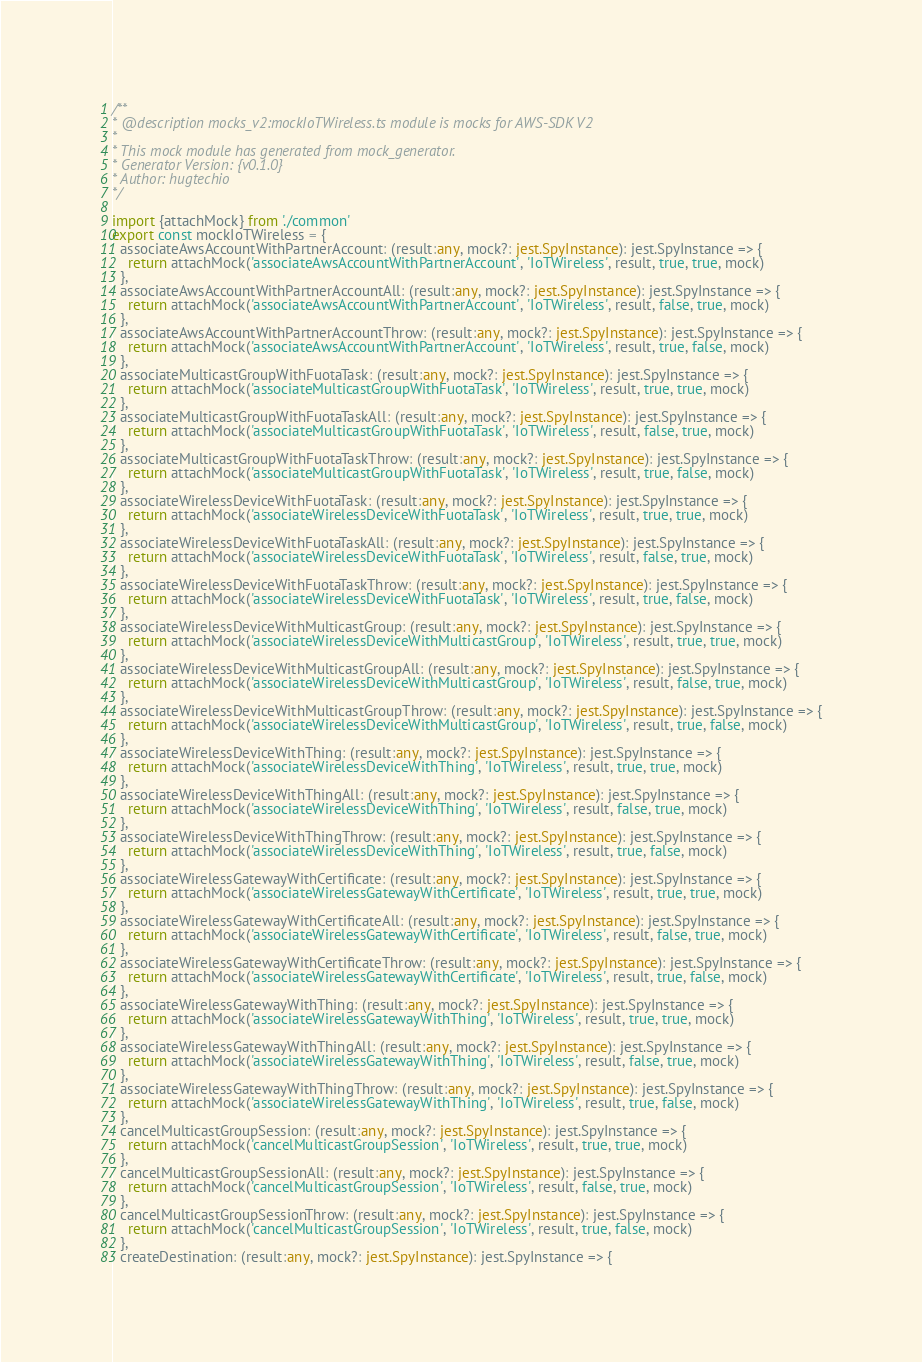<code> <loc_0><loc_0><loc_500><loc_500><_TypeScript_>
/**
* @description mocks_v2:mockIoTWireless.ts module is mocks for AWS-SDK V2
* 
* This mock module has generated from mock_generator.
* Generator Version: {v0.1.0}
* Author: hugtechio
*/

import {attachMock} from './common'
export const mockIoTWireless = {
  associateAwsAccountWithPartnerAccount: (result:any, mock?: jest.SpyInstance): jest.SpyInstance => {
    return attachMock('associateAwsAccountWithPartnerAccount', 'IoTWireless', result, true, true, mock)
  },
  associateAwsAccountWithPartnerAccountAll: (result:any, mock?: jest.SpyInstance): jest.SpyInstance => {
    return attachMock('associateAwsAccountWithPartnerAccount', 'IoTWireless', result, false, true, mock)
  },
  associateAwsAccountWithPartnerAccountThrow: (result:any, mock?: jest.SpyInstance): jest.SpyInstance => {
    return attachMock('associateAwsAccountWithPartnerAccount', 'IoTWireless', result, true, false, mock)
  },
  associateMulticastGroupWithFuotaTask: (result:any, mock?: jest.SpyInstance): jest.SpyInstance => {
    return attachMock('associateMulticastGroupWithFuotaTask', 'IoTWireless', result, true, true, mock)
  },
  associateMulticastGroupWithFuotaTaskAll: (result:any, mock?: jest.SpyInstance): jest.SpyInstance => {
    return attachMock('associateMulticastGroupWithFuotaTask', 'IoTWireless', result, false, true, mock)
  },
  associateMulticastGroupWithFuotaTaskThrow: (result:any, mock?: jest.SpyInstance): jest.SpyInstance => {
    return attachMock('associateMulticastGroupWithFuotaTask', 'IoTWireless', result, true, false, mock)
  },
  associateWirelessDeviceWithFuotaTask: (result:any, mock?: jest.SpyInstance): jest.SpyInstance => {
    return attachMock('associateWirelessDeviceWithFuotaTask', 'IoTWireless', result, true, true, mock)
  },
  associateWirelessDeviceWithFuotaTaskAll: (result:any, mock?: jest.SpyInstance): jest.SpyInstance => {
    return attachMock('associateWirelessDeviceWithFuotaTask', 'IoTWireless', result, false, true, mock)
  },
  associateWirelessDeviceWithFuotaTaskThrow: (result:any, mock?: jest.SpyInstance): jest.SpyInstance => {
    return attachMock('associateWirelessDeviceWithFuotaTask', 'IoTWireless', result, true, false, mock)
  },
  associateWirelessDeviceWithMulticastGroup: (result:any, mock?: jest.SpyInstance): jest.SpyInstance => {
    return attachMock('associateWirelessDeviceWithMulticastGroup', 'IoTWireless', result, true, true, mock)
  },
  associateWirelessDeviceWithMulticastGroupAll: (result:any, mock?: jest.SpyInstance): jest.SpyInstance => {
    return attachMock('associateWirelessDeviceWithMulticastGroup', 'IoTWireless', result, false, true, mock)
  },
  associateWirelessDeviceWithMulticastGroupThrow: (result:any, mock?: jest.SpyInstance): jest.SpyInstance => {
    return attachMock('associateWirelessDeviceWithMulticastGroup', 'IoTWireless', result, true, false, mock)
  },
  associateWirelessDeviceWithThing: (result:any, mock?: jest.SpyInstance): jest.SpyInstance => {
    return attachMock('associateWirelessDeviceWithThing', 'IoTWireless', result, true, true, mock)
  },
  associateWirelessDeviceWithThingAll: (result:any, mock?: jest.SpyInstance): jest.SpyInstance => {
    return attachMock('associateWirelessDeviceWithThing', 'IoTWireless', result, false, true, mock)
  },
  associateWirelessDeviceWithThingThrow: (result:any, mock?: jest.SpyInstance): jest.SpyInstance => {
    return attachMock('associateWirelessDeviceWithThing', 'IoTWireless', result, true, false, mock)
  },
  associateWirelessGatewayWithCertificate: (result:any, mock?: jest.SpyInstance): jest.SpyInstance => {
    return attachMock('associateWirelessGatewayWithCertificate', 'IoTWireless', result, true, true, mock)
  },
  associateWirelessGatewayWithCertificateAll: (result:any, mock?: jest.SpyInstance): jest.SpyInstance => {
    return attachMock('associateWirelessGatewayWithCertificate', 'IoTWireless', result, false, true, mock)
  },
  associateWirelessGatewayWithCertificateThrow: (result:any, mock?: jest.SpyInstance): jest.SpyInstance => {
    return attachMock('associateWirelessGatewayWithCertificate', 'IoTWireless', result, true, false, mock)
  },
  associateWirelessGatewayWithThing: (result:any, mock?: jest.SpyInstance): jest.SpyInstance => {
    return attachMock('associateWirelessGatewayWithThing', 'IoTWireless', result, true, true, mock)
  },
  associateWirelessGatewayWithThingAll: (result:any, mock?: jest.SpyInstance): jest.SpyInstance => {
    return attachMock('associateWirelessGatewayWithThing', 'IoTWireless', result, false, true, mock)
  },
  associateWirelessGatewayWithThingThrow: (result:any, mock?: jest.SpyInstance): jest.SpyInstance => {
    return attachMock('associateWirelessGatewayWithThing', 'IoTWireless', result, true, false, mock)
  },
  cancelMulticastGroupSession: (result:any, mock?: jest.SpyInstance): jest.SpyInstance => {
    return attachMock('cancelMulticastGroupSession', 'IoTWireless', result, true, true, mock)
  },
  cancelMulticastGroupSessionAll: (result:any, mock?: jest.SpyInstance): jest.SpyInstance => {
    return attachMock('cancelMulticastGroupSession', 'IoTWireless', result, false, true, mock)
  },
  cancelMulticastGroupSessionThrow: (result:any, mock?: jest.SpyInstance): jest.SpyInstance => {
    return attachMock('cancelMulticastGroupSession', 'IoTWireless', result, true, false, mock)
  },
  createDestination: (result:any, mock?: jest.SpyInstance): jest.SpyInstance => {</code> 